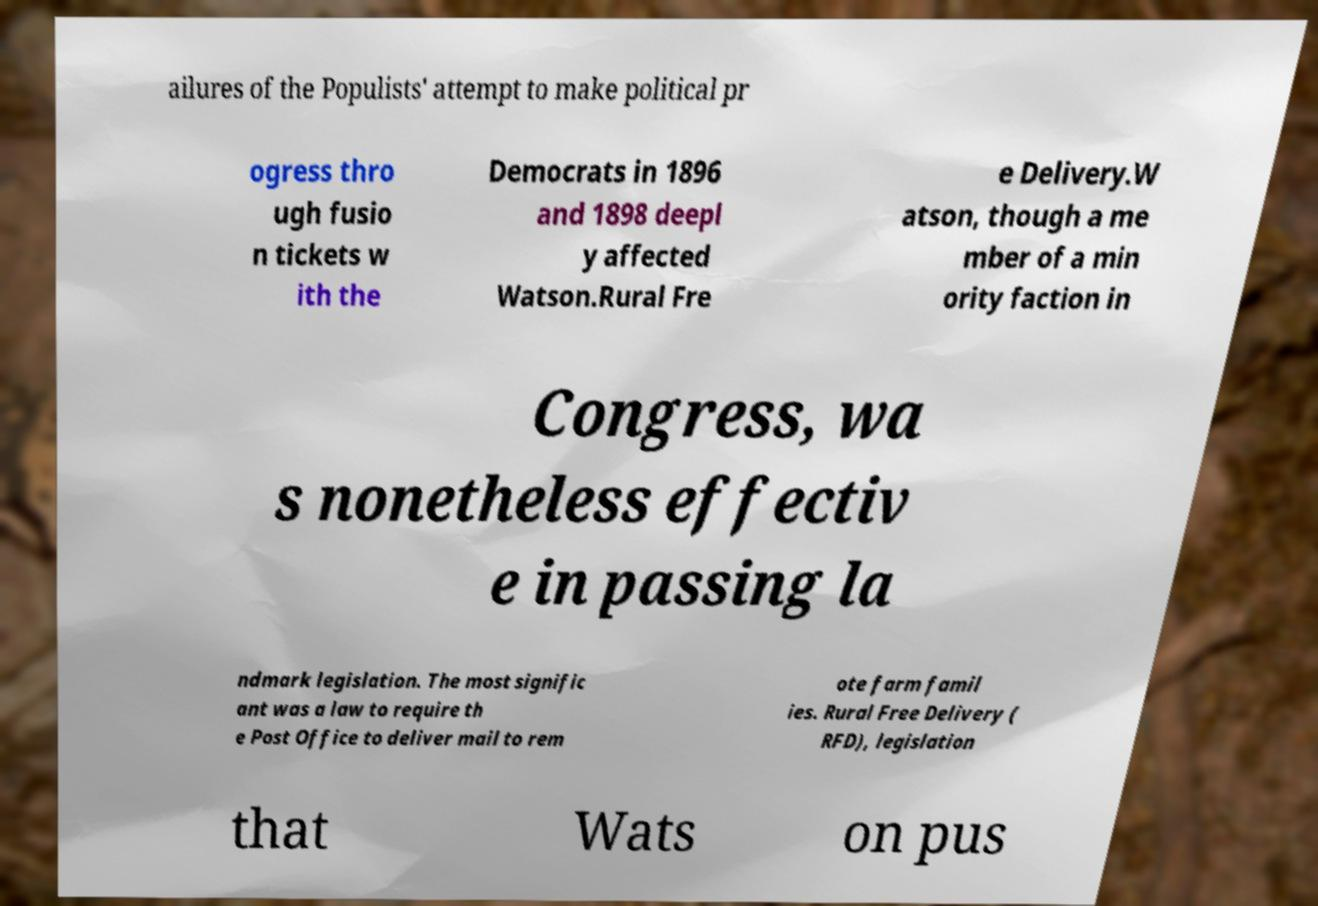Please read and relay the text visible in this image. What does it say? ailures of the Populists' attempt to make political pr ogress thro ugh fusio n tickets w ith the Democrats in 1896 and 1898 deepl y affected Watson.Rural Fre e Delivery.W atson, though a me mber of a min ority faction in Congress, wa s nonetheless effectiv e in passing la ndmark legislation. The most signific ant was a law to require th e Post Office to deliver mail to rem ote farm famil ies. Rural Free Delivery ( RFD), legislation that Wats on pus 